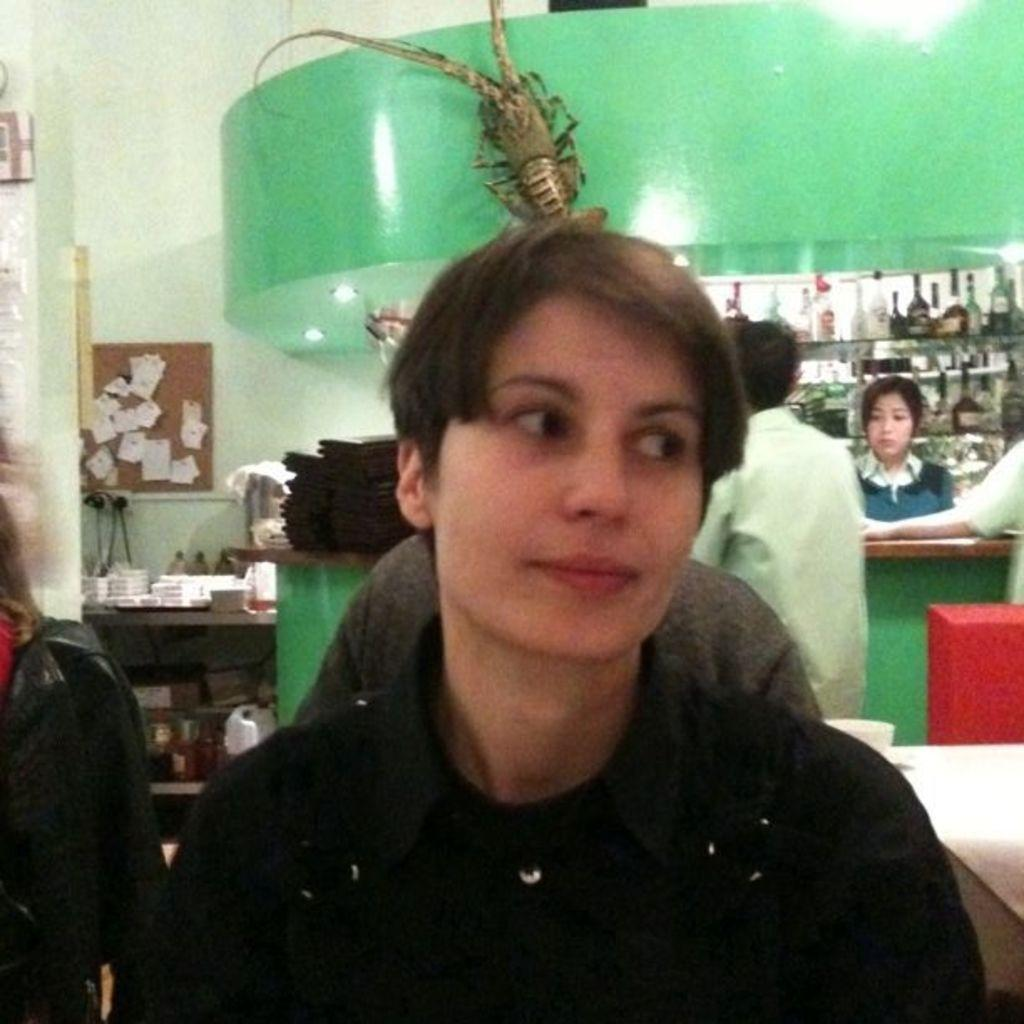What is the primary action of the person in the image? There is a person sitting in the image. Are there any other people visible in the image? Yes, there are other people behind the sitting person. What type of furniture or structure is present in the image? There are shelves in the image. What can be found on the shelves? There are things placed on the shelves. What color is the girl's tooth in the image? There is no girl or tooth present in the image. 